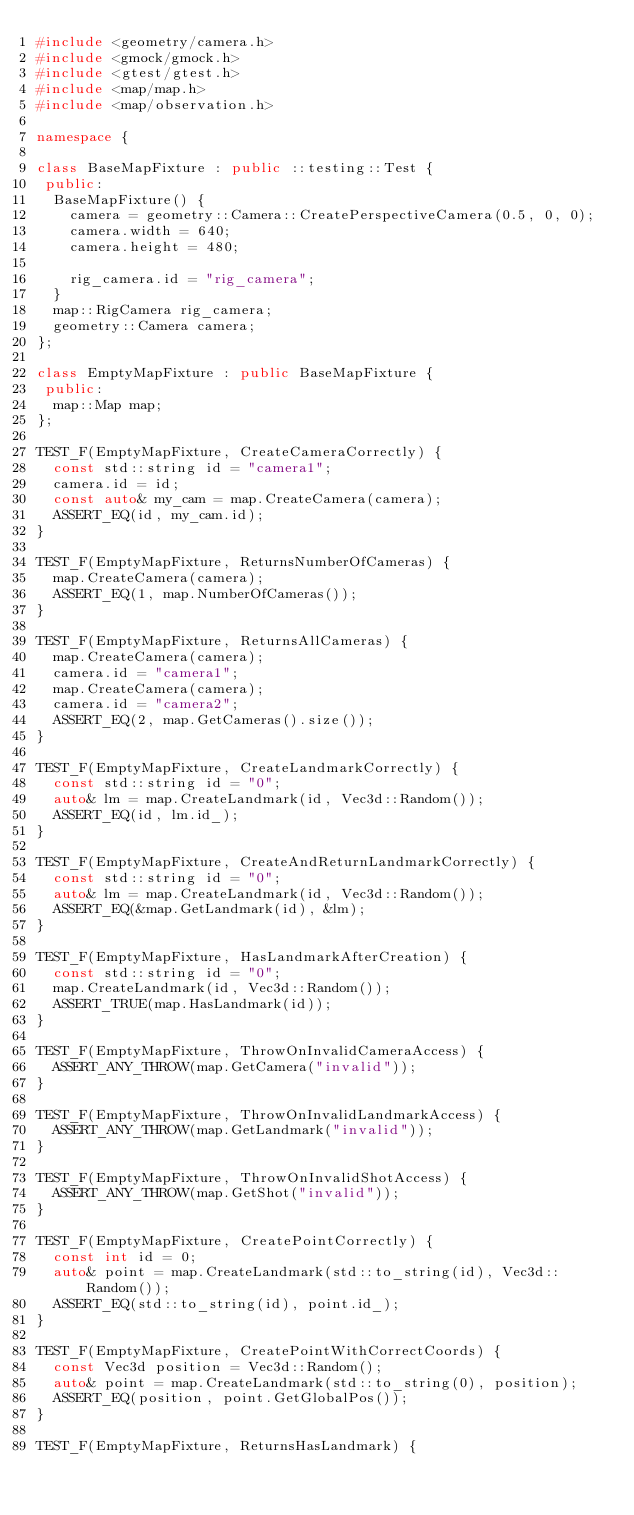<code> <loc_0><loc_0><loc_500><loc_500><_C++_>#include <geometry/camera.h>
#include <gmock/gmock.h>
#include <gtest/gtest.h>
#include <map/map.h>
#include <map/observation.h>

namespace {

class BaseMapFixture : public ::testing::Test {
 public:
  BaseMapFixture() {
    camera = geometry::Camera::CreatePerspectiveCamera(0.5, 0, 0);
    camera.width = 640;
    camera.height = 480;

    rig_camera.id = "rig_camera";
  }
  map::RigCamera rig_camera;
  geometry::Camera camera;
};

class EmptyMapFixture : public BaseMapFixture {
 public:
  map::Map map;
};

TEST_F(EmptyMapFixture, CreateCameraCorrectly) {
  const std::string id = "camera1";
  camera.id = id;
  const auto& my_cam = map.CreateCamera(camera);
  ASSERT_EQ(id, my_cam.id);
}

TEST_F(EmptyMapFixture, ReturnsNumberOfCameras) {
  map.CreateCamera(camera);
  ASSERT_EQ(1, map.NumberOfCameras());
}

TEST_F(EmptyMapFixture, ReturnsAllCameras) {
  map.CreateCamera(camera);
  camera.id = "camera1";
  map.CreateCamera(camera);
  camera.id = "camera2";
  ASSERT_EQ(2, map.GetCameras().size());
}

TEST_F(EmptyMapFixture, CreateLandmarkCorrectly) {
  const std::string id = "0";
  auto& lm = map.CreateLandmark(id, Vec3d::Random());
  ASSERT_EQ(id, lm.id_);
}

TEST_F(EmptyMapFixture, CreateAndReturnLandmarkCorrectly) {
  const std::string id = "0";
  auto& lm = map.CreateLandmark(id, Vec3d::Random());
  ASSERT_EQ(&map.GetLandmark(id), &lm);
}

TEST_F(EmptyMapFixture, HasLandmarkAfterCreation) {
  const std::string id = "0";
  map.CreateLandmark(id, Vec3d::Random());
  ASSERT_TRUE(map.HasLandmark(id));
}

TEST_F(EmptyMapFixture, ThrowOnInvalidCameraAccess) {
  ASSERT_ANY_THROW(map.GetCamera("invalid"));
}

TEST_F(EmptyMapFixture, ThrowOnInvalidLandmarkAccess) {
  ASSERT_ANY_THROW(map.GetLandmark("invalid"));
}

TEST_F(EmptyMapFixture, ThrowOnInvalidShotAccess) {
  ASSERT_ANY_THROW(map.GetShot("invalid"));
}

TEST_F(EmptyMapFixture, CreatePointCorrectly) {
  const int id = 0;
  auto& point = map.CreateLandmark(std::to_string(id), Vec3d::Random());
  ASSERT_EQ(std::to_string(id), point.id_);
}

TEST_F(EmptyMapFixture, CreatePointWithCorrectCoords) {
  const Vec3d position = Vec3d::Random();
  auto& point = map.CreateLandmark(std::to_string(0), position);
  ASSERT_EQ(position, point.GetGlobalPos());
}

TEST_F(EmptyMapFixture, ReturnsHasLandmark) {</code> 